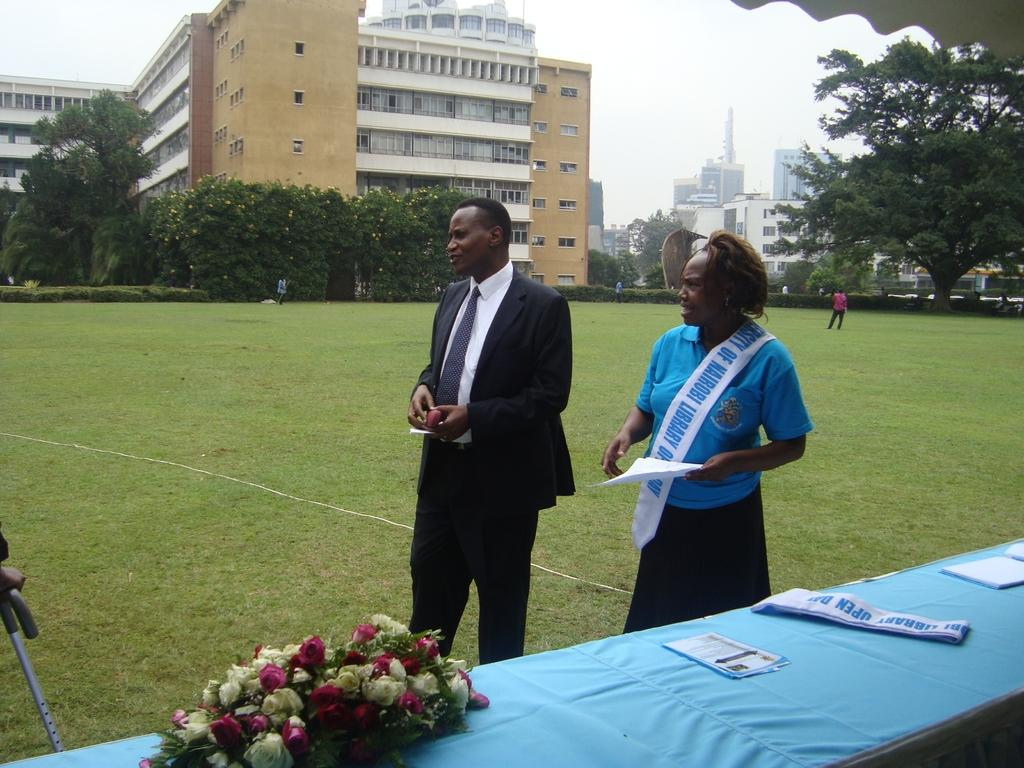What type of vegetation is present in the image? There is grass and trees in the image. What type of structures can be seen in the image? There are buildings in the image. What type of flora is present in the image? There are flowers in the image. Who or what is present in the image? There are people in the image. What type of furniture is visible in the image? There is a table in the image. What is visible at the top of the image? The sky is visible at the top of the image. What type of nose can be seen on the flowers in the image? There are no noses present on the flowers in the image, as flowers do not have noses. What type of linen is draped over the table in the image? There is no linen present on the table in the image. What type of sweater is being worn by the trees in the image? Trees do not wear sweaters, as they are not human or animal. 